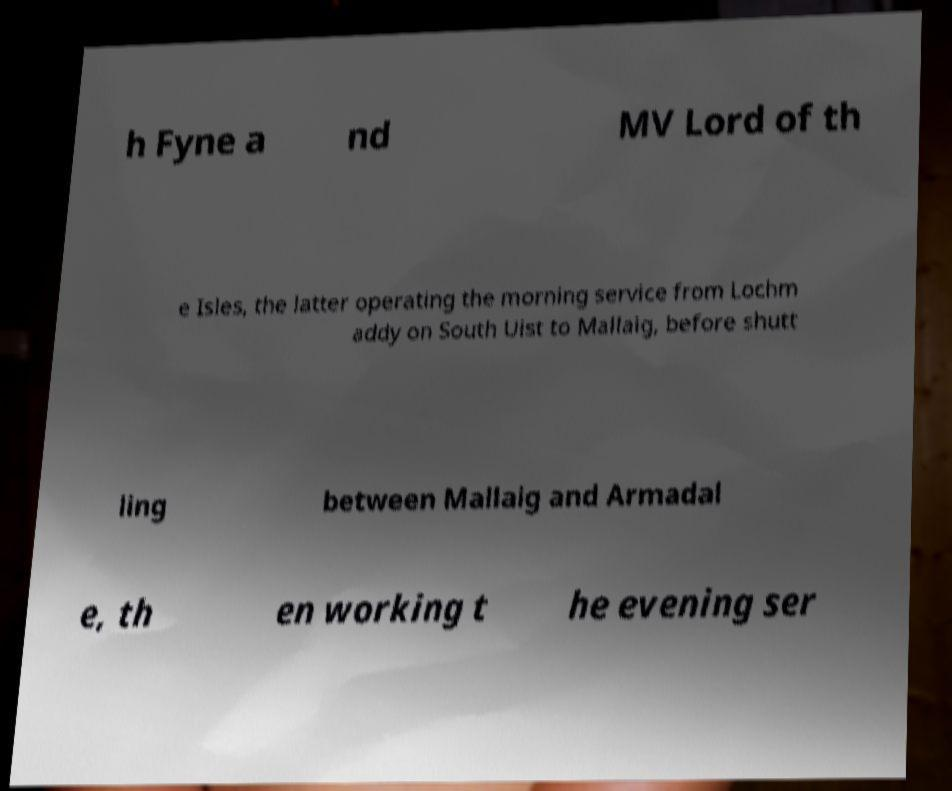There's text embedded in this image that I need extracted. Can you transcribe it verbatim? h Fyne a nd MV Lord of th e Isles, the latter operating the morning service from Lochm addy on South Uist to Mallaig, before shutt ling between Mallaig and Armadal e, th en working t he evening ser 